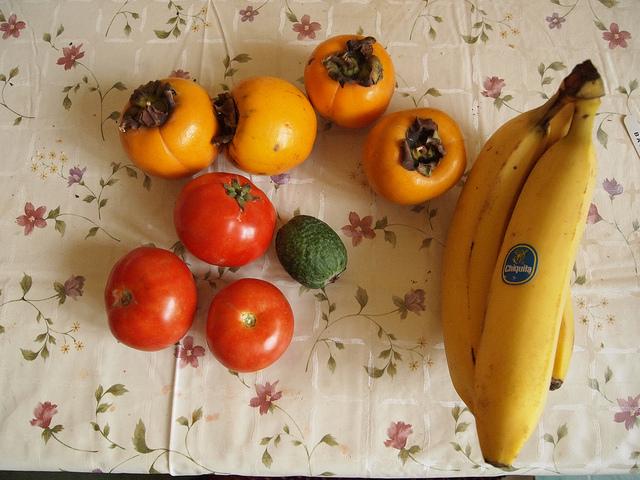What brand are the bananas?
Short answer required. Chiquita. How many tomatoes?
Short answer required. 7. Is the food ripe yet?
Be succinct. Yes. 